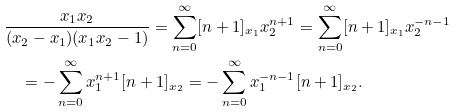<formula> <loc_0><loc_0><loc_500><loc_500>& \frac { x _ { 1 } x _ { 2 } } { ( x _ { 2 } - x _ { 1 } ) ( x _ { 1 } x _ { 2 } - 1 ) } = \sum _ { n = 0 } ^ { \infty } [ n + 1 ] _ { x _ { 1 } } x _ { 2 } ^ { n + 1 } = \sum _ { n = 0 } ^ { \infty } [ n + 1 ] _ { x _ { 1 } } x _ { 2 } ^ { - n - 1 } \\ & \quad = - \sum _ { n = 0 } ^ { \infty } x _ { 1 } ^ { n + 1 } [ n + 1 ] _ { x _ { 2 } } = - \sum _ { n = 0 } ^ { \infty } x _ { 1 } ^ { - n - 1 } [ n + 1 ] _ { x _ { 2 } } .</formula> 